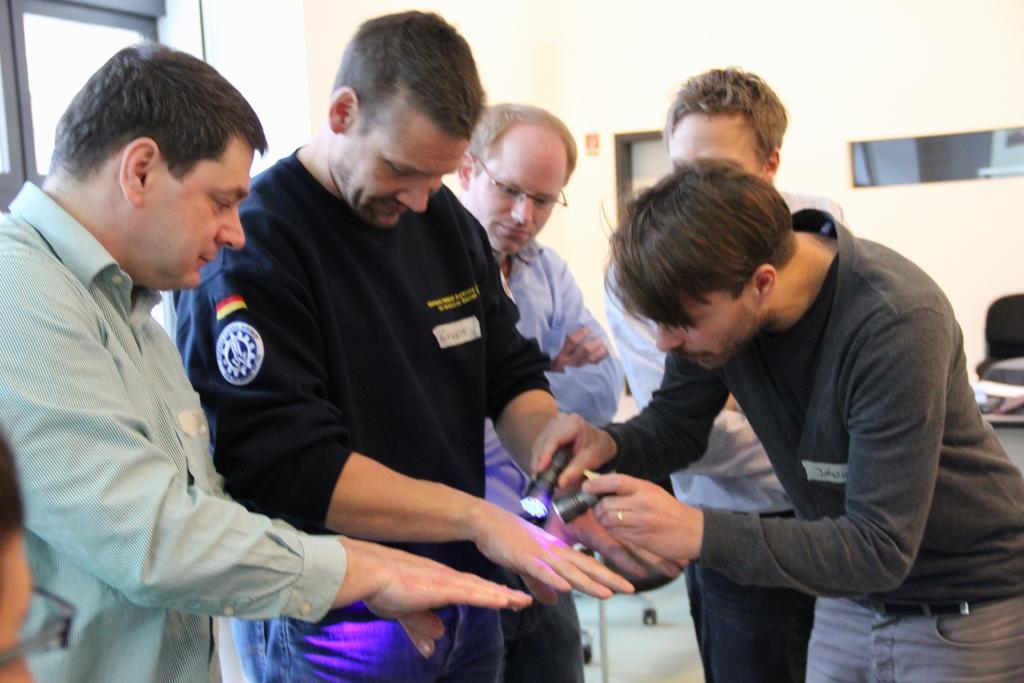Can you describe this image briefly? In this image we can see some people are standing, one glass window, one sticker attached to the wall, one man sitting left side corner of the image, one chair near to the table, some objects on the table, one man holding two torch lights and some objects on the floor. 